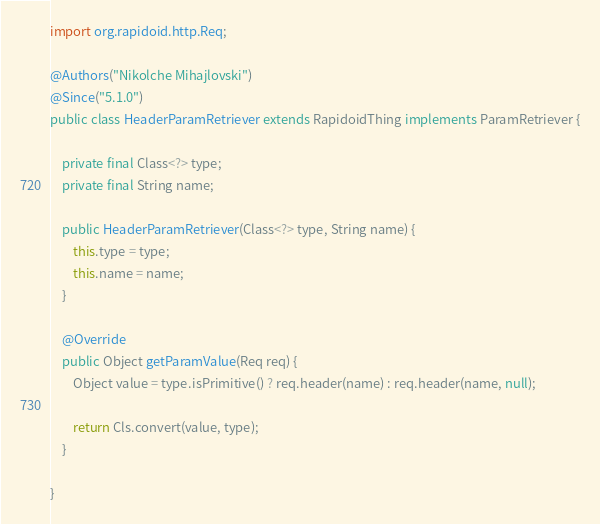<code> <loc_0><loc_0><loc_500><loc_500><_Java_>import org.rapidoid.http.Req;

@Authors("Nikolche Mihajlovski")
@Since("5.1.0")
public class HeaderParamRetriever extends RapidoidThing implements ParamRetriever {

	private final Class<?> type;
	private final String name;

	public HeaderParamRetriever(Class<?> type, String name) {
		this.type = type;
		this.name = name;
	}

	@Override
	public Object getParamValue(Req req) {
		Object value = type.isPrimitive() ? req.header(name) : req.header(name, null);

		return Cls.convert(value, type);
	}

}
</code> 